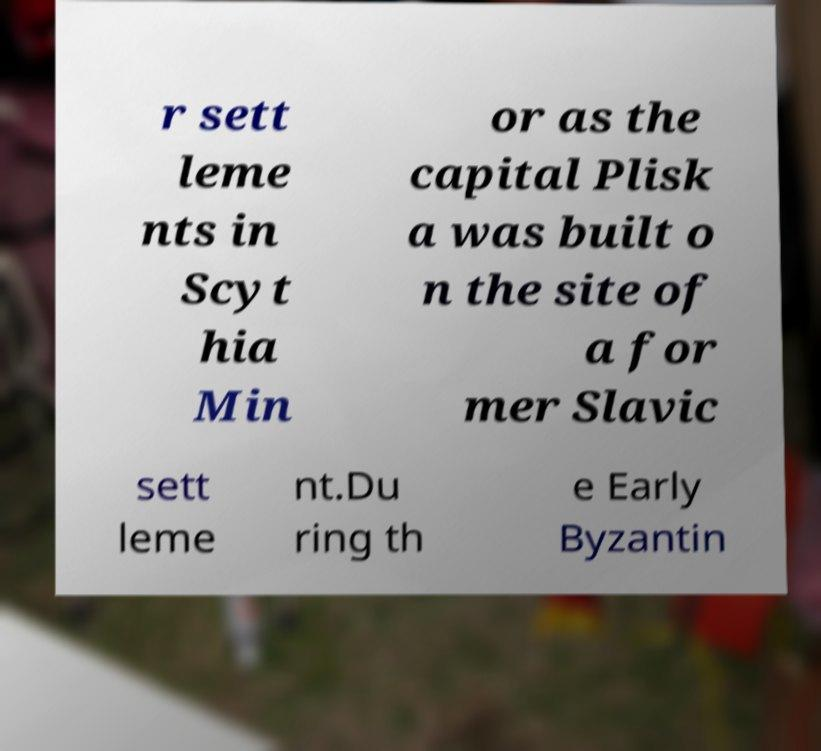Could you assist in decoding the text presented in this image and type it out clearly? r sett leme nts in Scyt hia Min or as the capital Plisk a was built o n the site of a for mer Slavic sett leme nt.Du ring th e Early Byzantin 